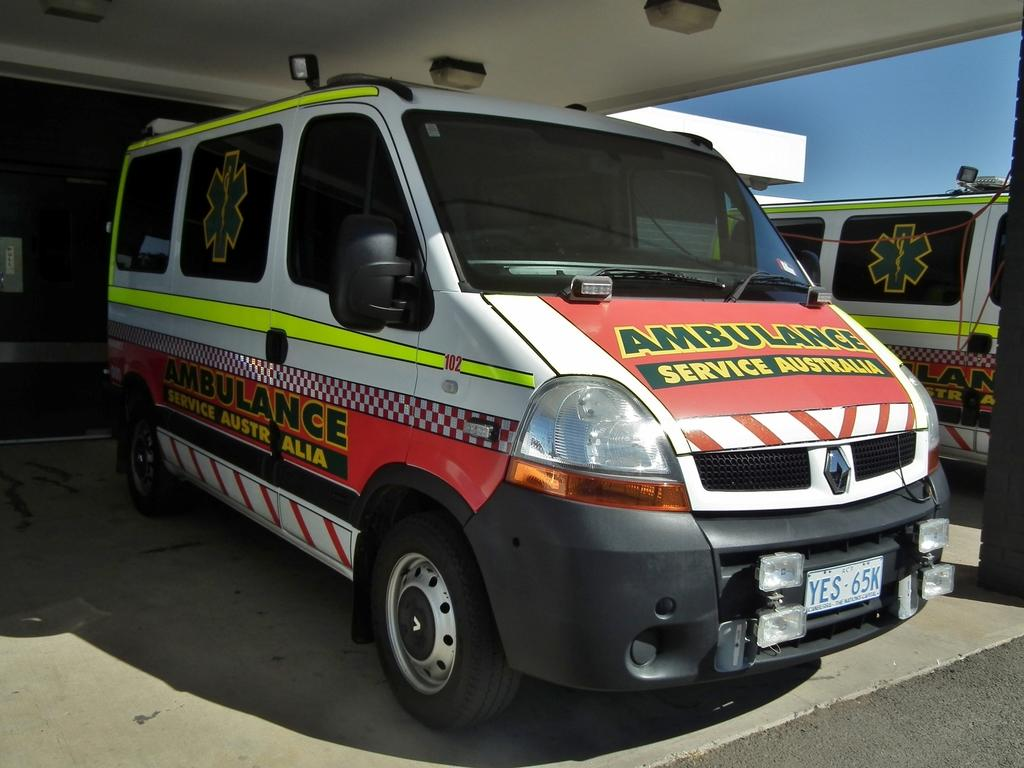What is the main subject of the image? The main subject of the image is cars. What can be seen on the cars? There is text written on the cars. What is visible in the background of the image? There is a building in the background of the image. What is on top of the building? There are lights on the roof of the building. Where is the scarecrow standing in the image? There is no scarecrow present in the image. How many horses can be seen in the image? There are no horses present in the image. 